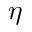Convert formula to latex. <formula><loc_0><loc_0><loc_500><loc_500>\eta</formula> 